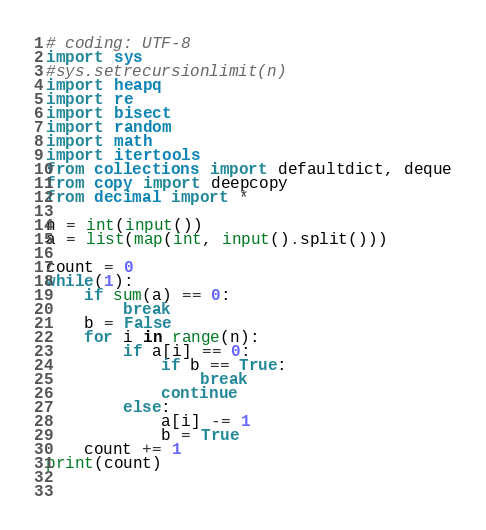<code> <loc_0><loc_0><loc_500><loc_500><_Python_># coding: UTF-8
import sys
#sys.setrecursionlimit(n)
import heapq
import re
import bisect
import random
import math
import itertools
from collections import defaultdict, deque
from copy import deepcopy
from decimal import *

n = int(input())
a = list(map(int, input().split()))

count = 0
while(1):
    if sum(a) == 0:
        break
    b = False
    for i in range(n):
        if a[i] == 0:
            if b == True:
                break
            continue
        else:
            a[i] -= 1
            b = True
    count += 1
print(count)

    </code> 